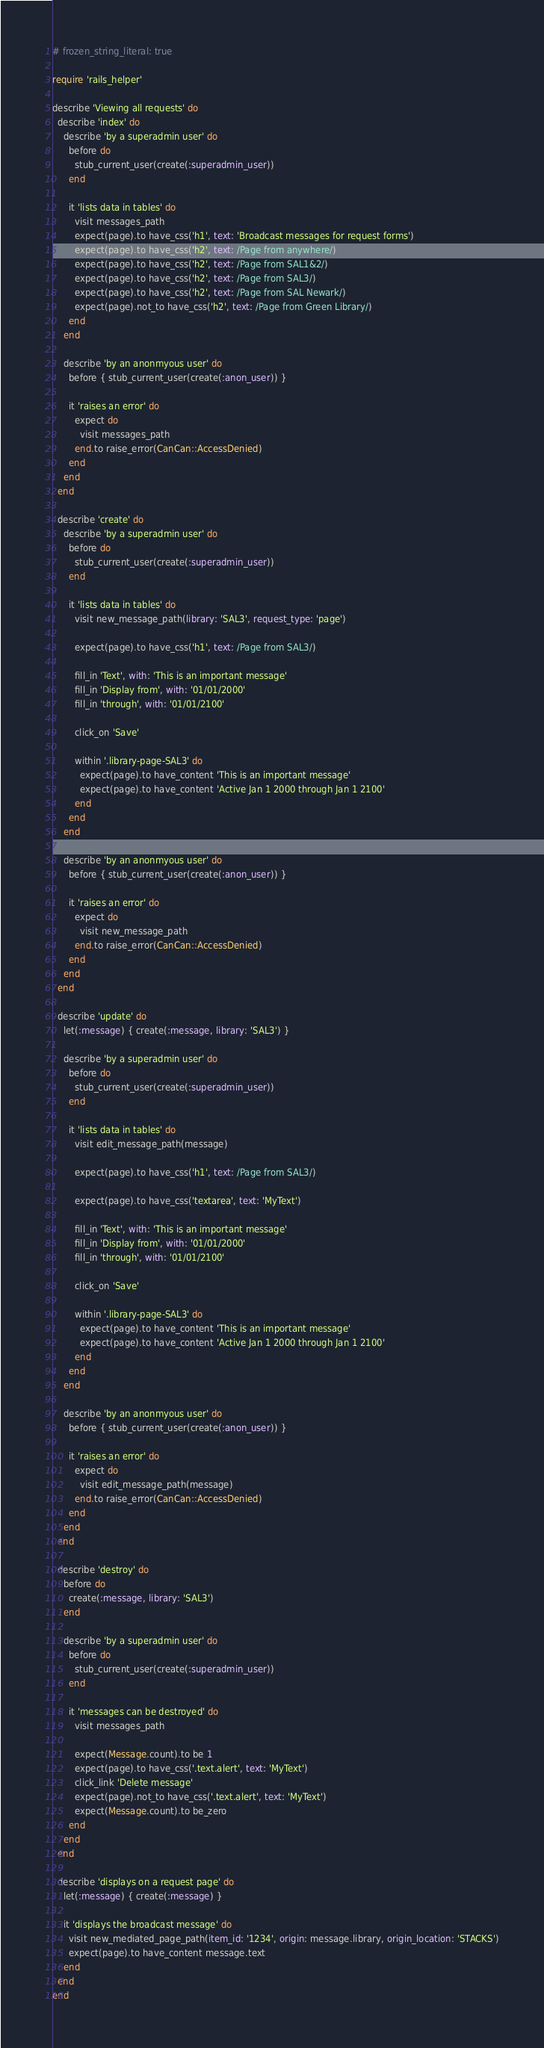Convert code to text. <code><loc_0><loc_0><loc_500><loc_500><_Ruby_># frozen_string_literal: true

require 'rails_helper'

describe 'Viewing all requests' do
  describe 'index' do
    describe 'by a superadmin user' do
      before do
        stub_current_user(create(:superadmin_user))
      end

      it 'lists data in tables' do
        visit messages_path
        expect(page).to have_css('h1', text: 'Broadcast messages for request forms')
        expect(page).to have_css('h2', text: /Page from anywhere/)
        expect(page).to have_css('h2', text: /Page from SAL1&2/)
        expect(page).to have_css('h2', text: /Page from SAL3/)
        expect(page).to have_css('h2', text: /Page from SAL Newark/)
        expect(page).not_to have_css('h2', text: /Page from Green Library/)
      end
    end

    describe 'by an anonmyous user' do
      before { stub_current_user(create(:anon_user)) }

      it 'raises an error' do
        expect do
          visit messages_path
        end.to raise_error(CanCan::AccessDenied)
      end
    end
  end

  describe 'create' do
    describe 'by a superadmin user' do
      before do
        stub_current_user(create(:superadmin_user))
      end

      it 'lists data in tables' do
        visit new_message_path(library: 'SAL3', request_type: 'page')

        expect(page).to have_css('h1', text: /Page from SAL3/)

        fill_in 'Text', with: 'This is an important message'
        fill_in 'Display from', with: '01/01/2000'
        fill_in 'through', with: '01/01/2100'

        click_on 'Save'

        within '.library-page-SAL3' do
          expect(page).to have_content 'This is an important message'
          expect(page).to have_content 'Active Jan 1 2000 through Jan 1 2100'
        end
      end
    end

    describe 'by an anonmyous user' do
      before { stub_current_user(create(:anon_user)) }

      it 'raises an error' do
        expect do
          visit new_message_path
        end.to raise_error(CanCan::AccessDenied)
      end
    end
  end

  describe 'update' do
    let(:message) { create(:message, library: 'SAL3') }

    describe 'by a superadmin user' do
      before do
        stub_current_user(create(:superadmin_user))
      end

      it 'lists data in tables' do
        visit edit_message_path(message)

        expect(page).to have_css('h1', text: /Page from SAL3/)

        expect(page).to have_css('textarea', text: 'MyText')

        fill_in 'Text', with: 'This is an important message'
        fill_in 'Display from', with: '01/01/2000'
        fill_in 'through', with: '01/01/2100'

        click_on 'Save'

        within '.library-page-SAL3' do
          expect(page).to have_content 'This is an important message'
          expect(page).to have_content 'Active Jan 1 2000 through Jan 1 2100'
        end
      end
    end

    describe 'by an anonmyous user' do
      before { stub_current_user(create(:anon_user)) }

      it 'raises an error' do
        expect do
          visit edit_message_path(message)
        end.to raise_error(CanCan::AccessDenied)
      end
    end
  end

  describe 'destroy' do
    before do
      create(:message, library: 'SAL3')
    end

    describe 'by a superadmin user' do
      before do
        stub_current_user(create(:superadmin_user))
      end

      it 'messages can be destroyed' do
        visit messages_path

        expect(Message.count).to be 1
        expect(page).to have_css('.text.alert', text: 'MyText')
        click_link 'Delete message'
        expect(page).not_to have_css('.text.alert', text: 'MyText')
        expect(Message.count).to be_zero
      end
    end
  end

  describe 'displays on a request page' do
    let(:message) { create(:message) }

    it 'displays the broadcast message' do
      visit new_mediated_page_path(item_id: '1234', origin: message.library, origin_location: 'STACKS')
      expect(page).to have_content message.text
    end
  end
end
</code> 